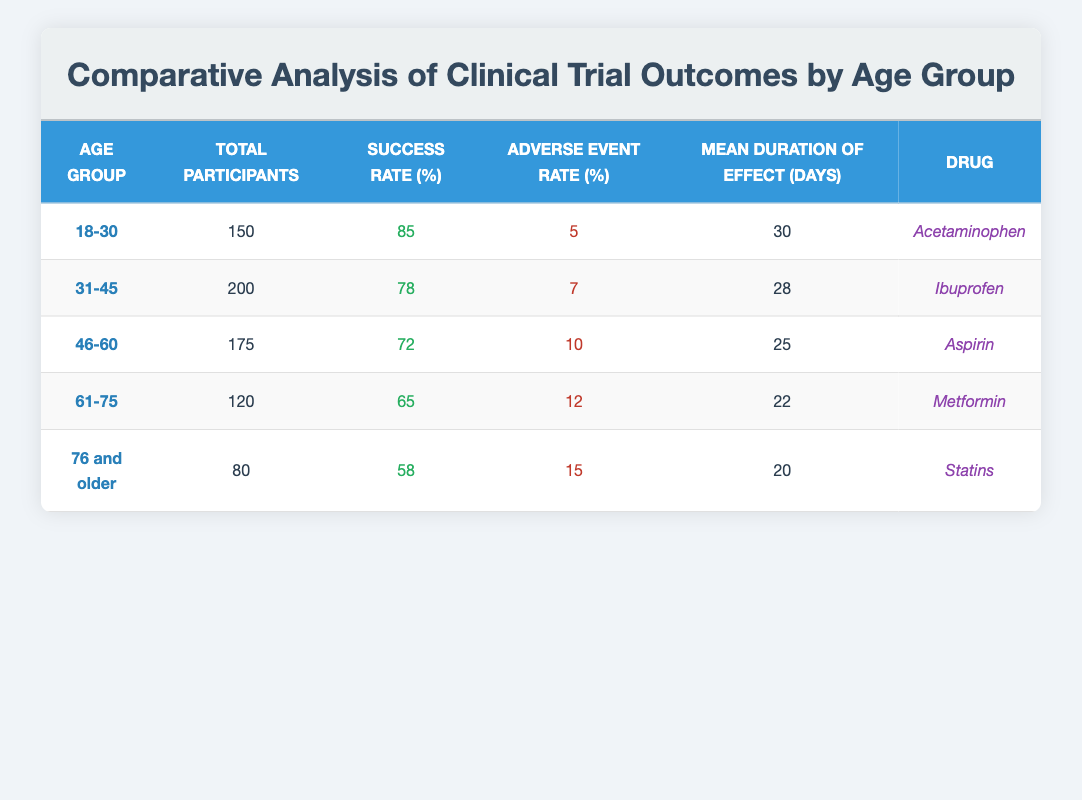What is the success rate for the age group 46-60? The success rate for the age group 46-60 is listed directly in the table under the "Success Rate (%)" column for that age group.
Answer: 72 How many total participants were in the age group 31-45? The total number of participants in the age group 31-45 is provided directly in the "Total Participants" column corresponding to that group.
Answer: 200 What is the average adverse event rate across all age groups? To find the average adverse event rate, sum the adverse event rates (5 + 7 + 10 + 12 + 15 = 49) and divide by the number of age groups (5). Thus, the average is 49/5 = 9.8.
Answer: 9.8 For which age group is the mean duration of effect the highest, and what is that duration? The mean duration of effect is found in the relevant column for each age group. Comparing the values (30, 28, 25, 22, 20) shows that the age group 18-30 has the highest duration of 30 days.
Answer: 18-30, 30 days Is the adverse event rate higher for participants aged 61-75 compared to those aged 18-30? The adverse event rate for the age group 61-75 is 12%, whereas for 18-30 it is 5%. Since 12% is greater than 5%, the statement is true.
Answer: Yes What percentage decrease in success rate occurs from the 18-30 age group to the 61-75 age group? To find the percentage decrease, first calculate the difference in success rates (85 - 65 = 20). Then, divide that difference by the original rate (20/85) and multiply by 100 to convert to percentage, resulting in approximately 23.53%.
Answer: 23.53% Are the total participants aged 76 and older less than those aged 31-45? The total participants for the age group 76 and older is 80, while for the 31-45 age group, it is 200. Since 80 is less than 200, the statement is true.
Answer: Yes What drug was associated with the highest success rate, and what was that success rate? By examining the "Success Rate (%)" column, the drug associated with the highest success rate is Acetaminophen at 85%.
Answer: Acetaminophen, 85% 